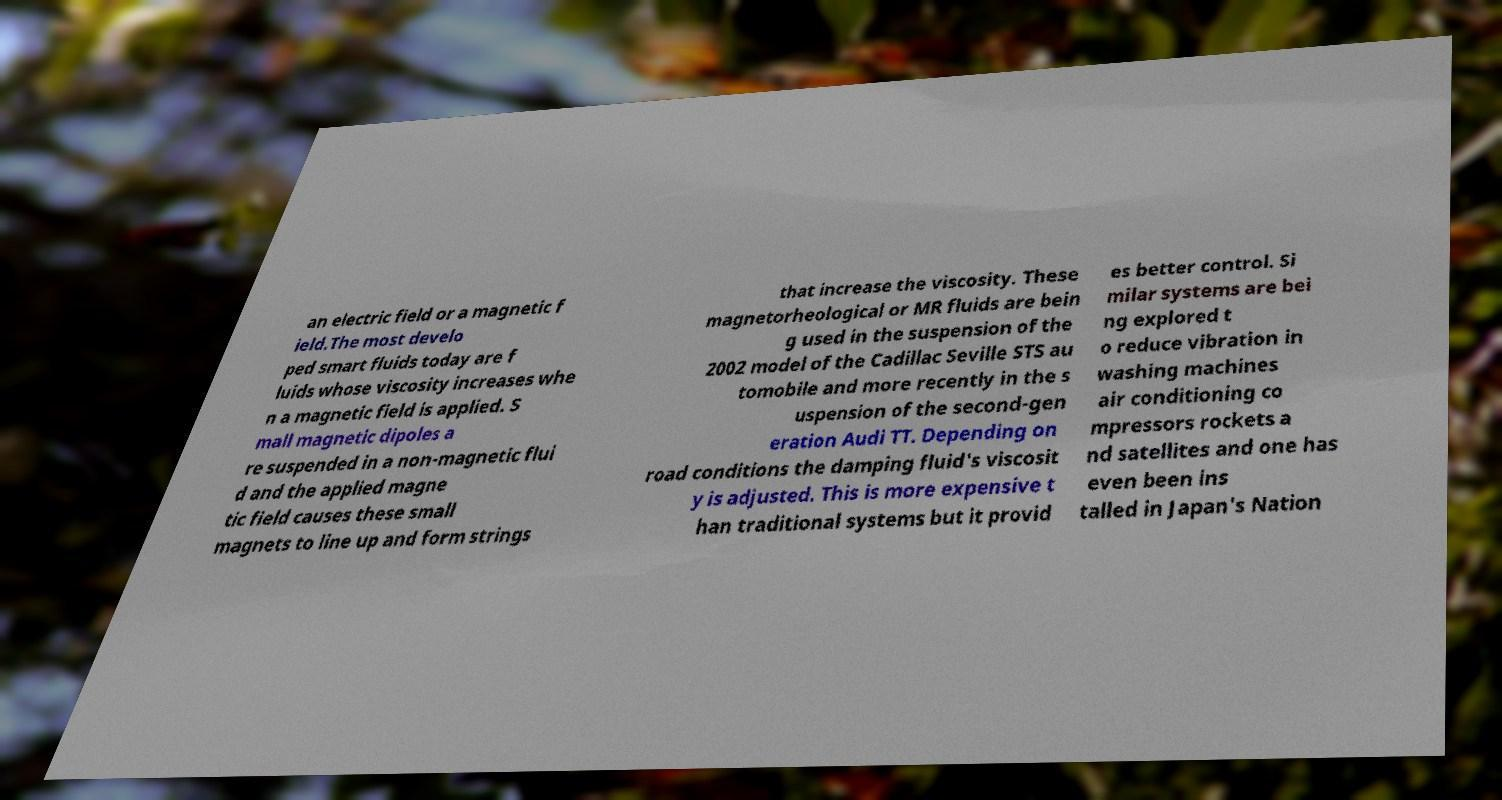Can you accurately transcribe the text from the provided image for me? an electric field or a magnetic f ield.The most develo ped smart fluids today are f luids whose viscosity increases whe n a magnetic field is applied. S mall magnetic dipoles a re suspended in a non-magnetic flui d and the applied magne tic field causes these small magnets to line up and form strings that increase the viscosity. These magnetorheological or MR fluids are bein g used in the suspension of the 2002 model of the Cadillac Seville STS au tomobile and more recently in the s uspension of the second-gen eration Audi TT. Depending on road conditions the damping fluid's viscosit y is adjusted. This is more expensive t han traditional systems but it provid es better control. Si milar systems are bei ng explored t o reduce vibration in washing machines air conditioning co mpressors rockets a nd satellites and one has even been ins talled in Japan's Nation 